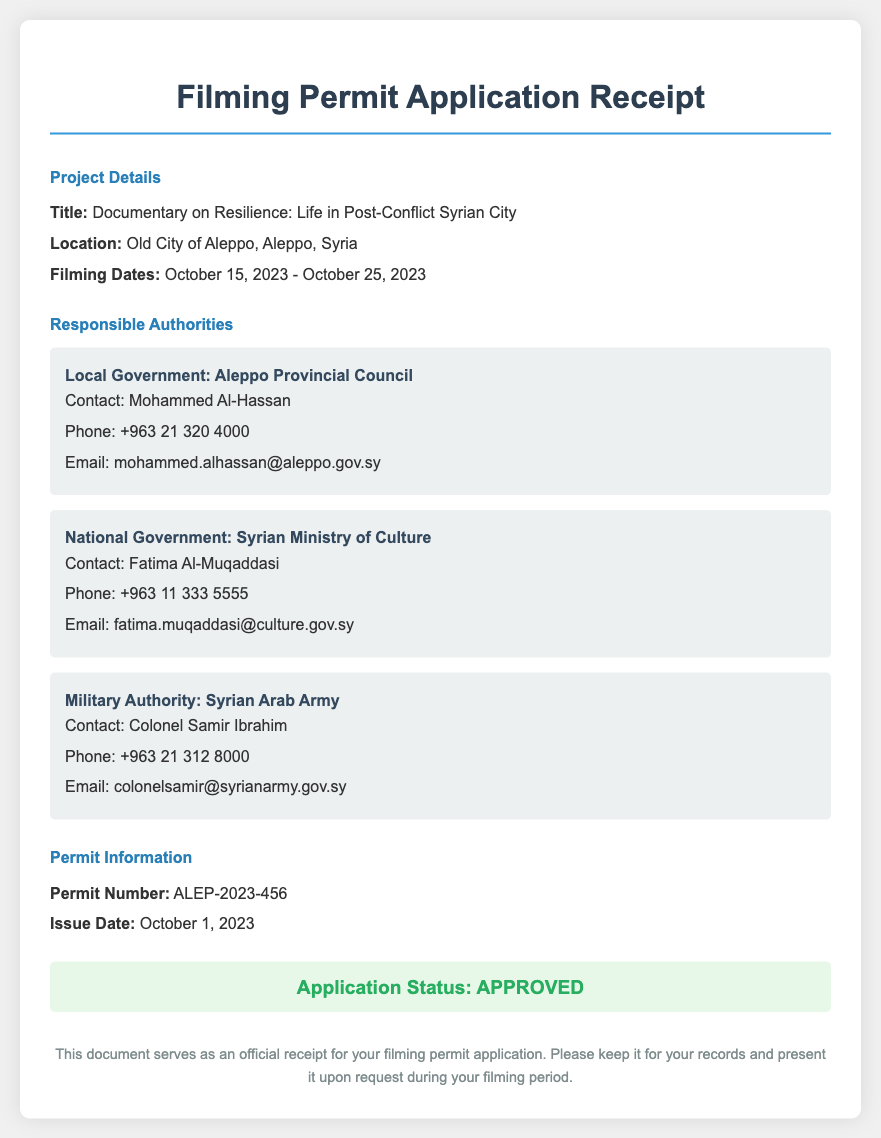What is the title of the documentary? The title is specified in the document under Project Details.
Answer: Documentary on Resilience: Life in Post-Conflict Syrian City What are the filming dates? The filming dates are provided in the Project Details section.
Answer: October 15, 2023 - October 25, 2023 Who is the contact person for the Local Government? The document lists the contact person for the Local Government authority in the Responsible Authorities section.
Answer: Mohammed Al-Hassan What is the permit number? The permit number is stated in the Permit Information section of the document.
Answer: ALEP-2023-456 Who is the contact for the Military Authority? The contact for the military authority is outlined in the Responsible Authorities section.
Answer: Colonel Samir Ibrahim What is the issue date of the permit? The issue date can be found in the Permit Information section.
Answer: October 1, 2023 Which government is the National Government authority? The document specifies the relevant authority under the Responsible Authorities section.
Answer: Syrian Ministry of Culture What is the application status? The application status is clearly stated in the last section of the document.
Answer: APPROVED 